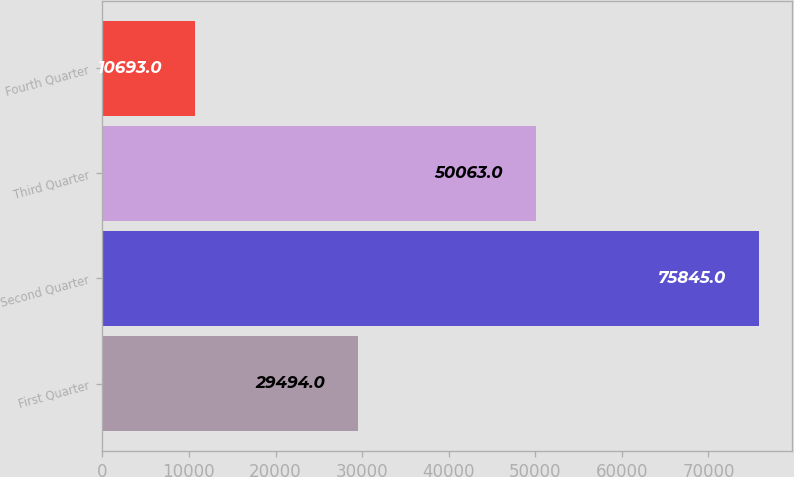Convert chart to OTSL. <chart><loc_0><loc_0><loc_500><loc_500><bar_chart><fcel>First Quarter<fcel>Second Quarter<fcel>Third Quarter<fcel>Fourth Quarter<nl><fcel>29494<fcel>75845<fcel>50063<fcel>10693<nl></chart> 